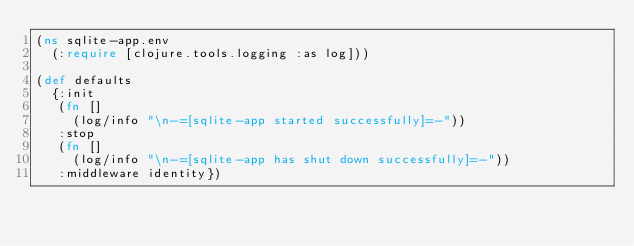Convert code to text. <code><loc_0><loc_0><loc_500><loc_500><_Clojure_>(ns sqlite-app.env
  (:require [clojure.tools.logging :as log]))

(def defaults
  {:init
   (fn []
     (log/info "\n-=[sqlite-app started successfully]=-"))
   :stop
   (fn []
     (log/info "\n-=[sqlite-app has shut down successfully]=-"))
   :middleware identity})
</code> 